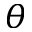Convert formula to latex. <formula><loc_0><loc_0><loc_500><loc_500>\theta</formula> 